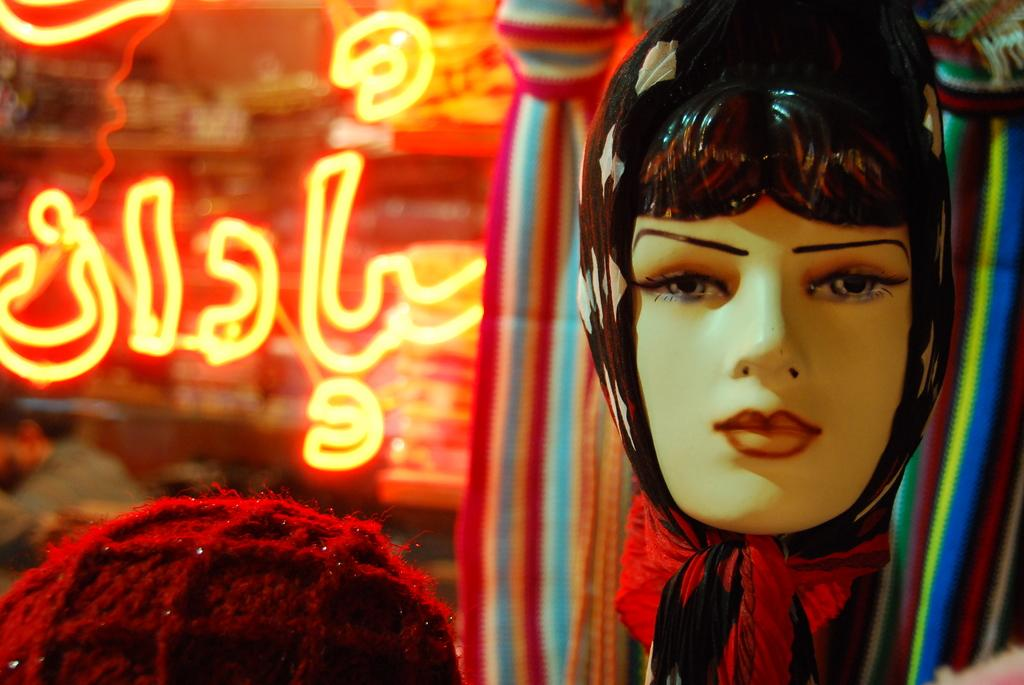What is the main subject of the image? There is a female mannequin head in the image. What else can be seen in the image besides the mannequin head? There is text visible in the image, as well as lights. Can you describe the background of the image? The background of the image is blurry. How does the dog contribute to the digestion process in the image? There is no dog present in the image, so it cannot contribute to any digestion process. 